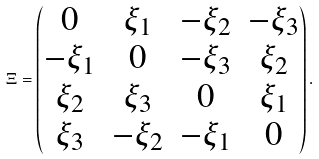<formula> <loc_0><loc_0><loc_500><loc_500>\Xi = \begin{pmatrix} 0 & \xi _ { 1 } & - \xi _ { 2 } & - \xi _ { 3 } \\ - \xi _ { 1 } & 0 & - \xi _ { 3 } & \xi _ { 2 } \\ \xi _ { 2 } & \xi _ { 3 } & 0 & \xi _ { 1 } \\ \xi _ { 3 } & - \xi _ { 2 } & - \xi _ { 1 } & 0 \end{pmatrix} .</formula> 